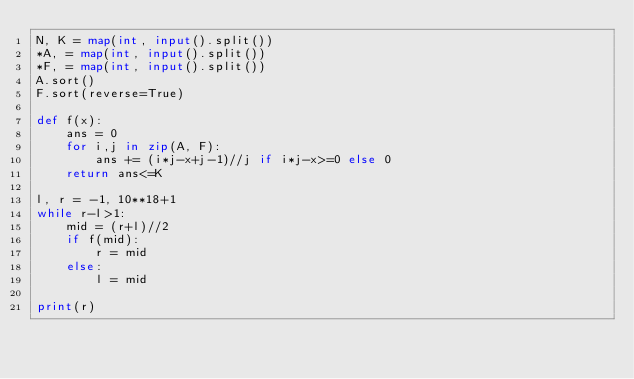Convert code to text. <code><loc_0><loc_0><loc_500><loc_500><_Python_>N, K = map(int, input().split())
*A, = map(int, input().split())
*F, = map(int, input().split())
A.sort()
F.sort(reverse=True)

def f(x):
    ans = 0
    for i,j in zip(A, F):
        ans += (i*j-x+j-1)//j if i*j-x>=0 else 0
    return ans<=K

l, r = -1, 10**18+1
while r-l>1:
    mid = (r+l)//2
    if f(mid):
        r = mid
    else:
        l = mid

print(r)</code> 